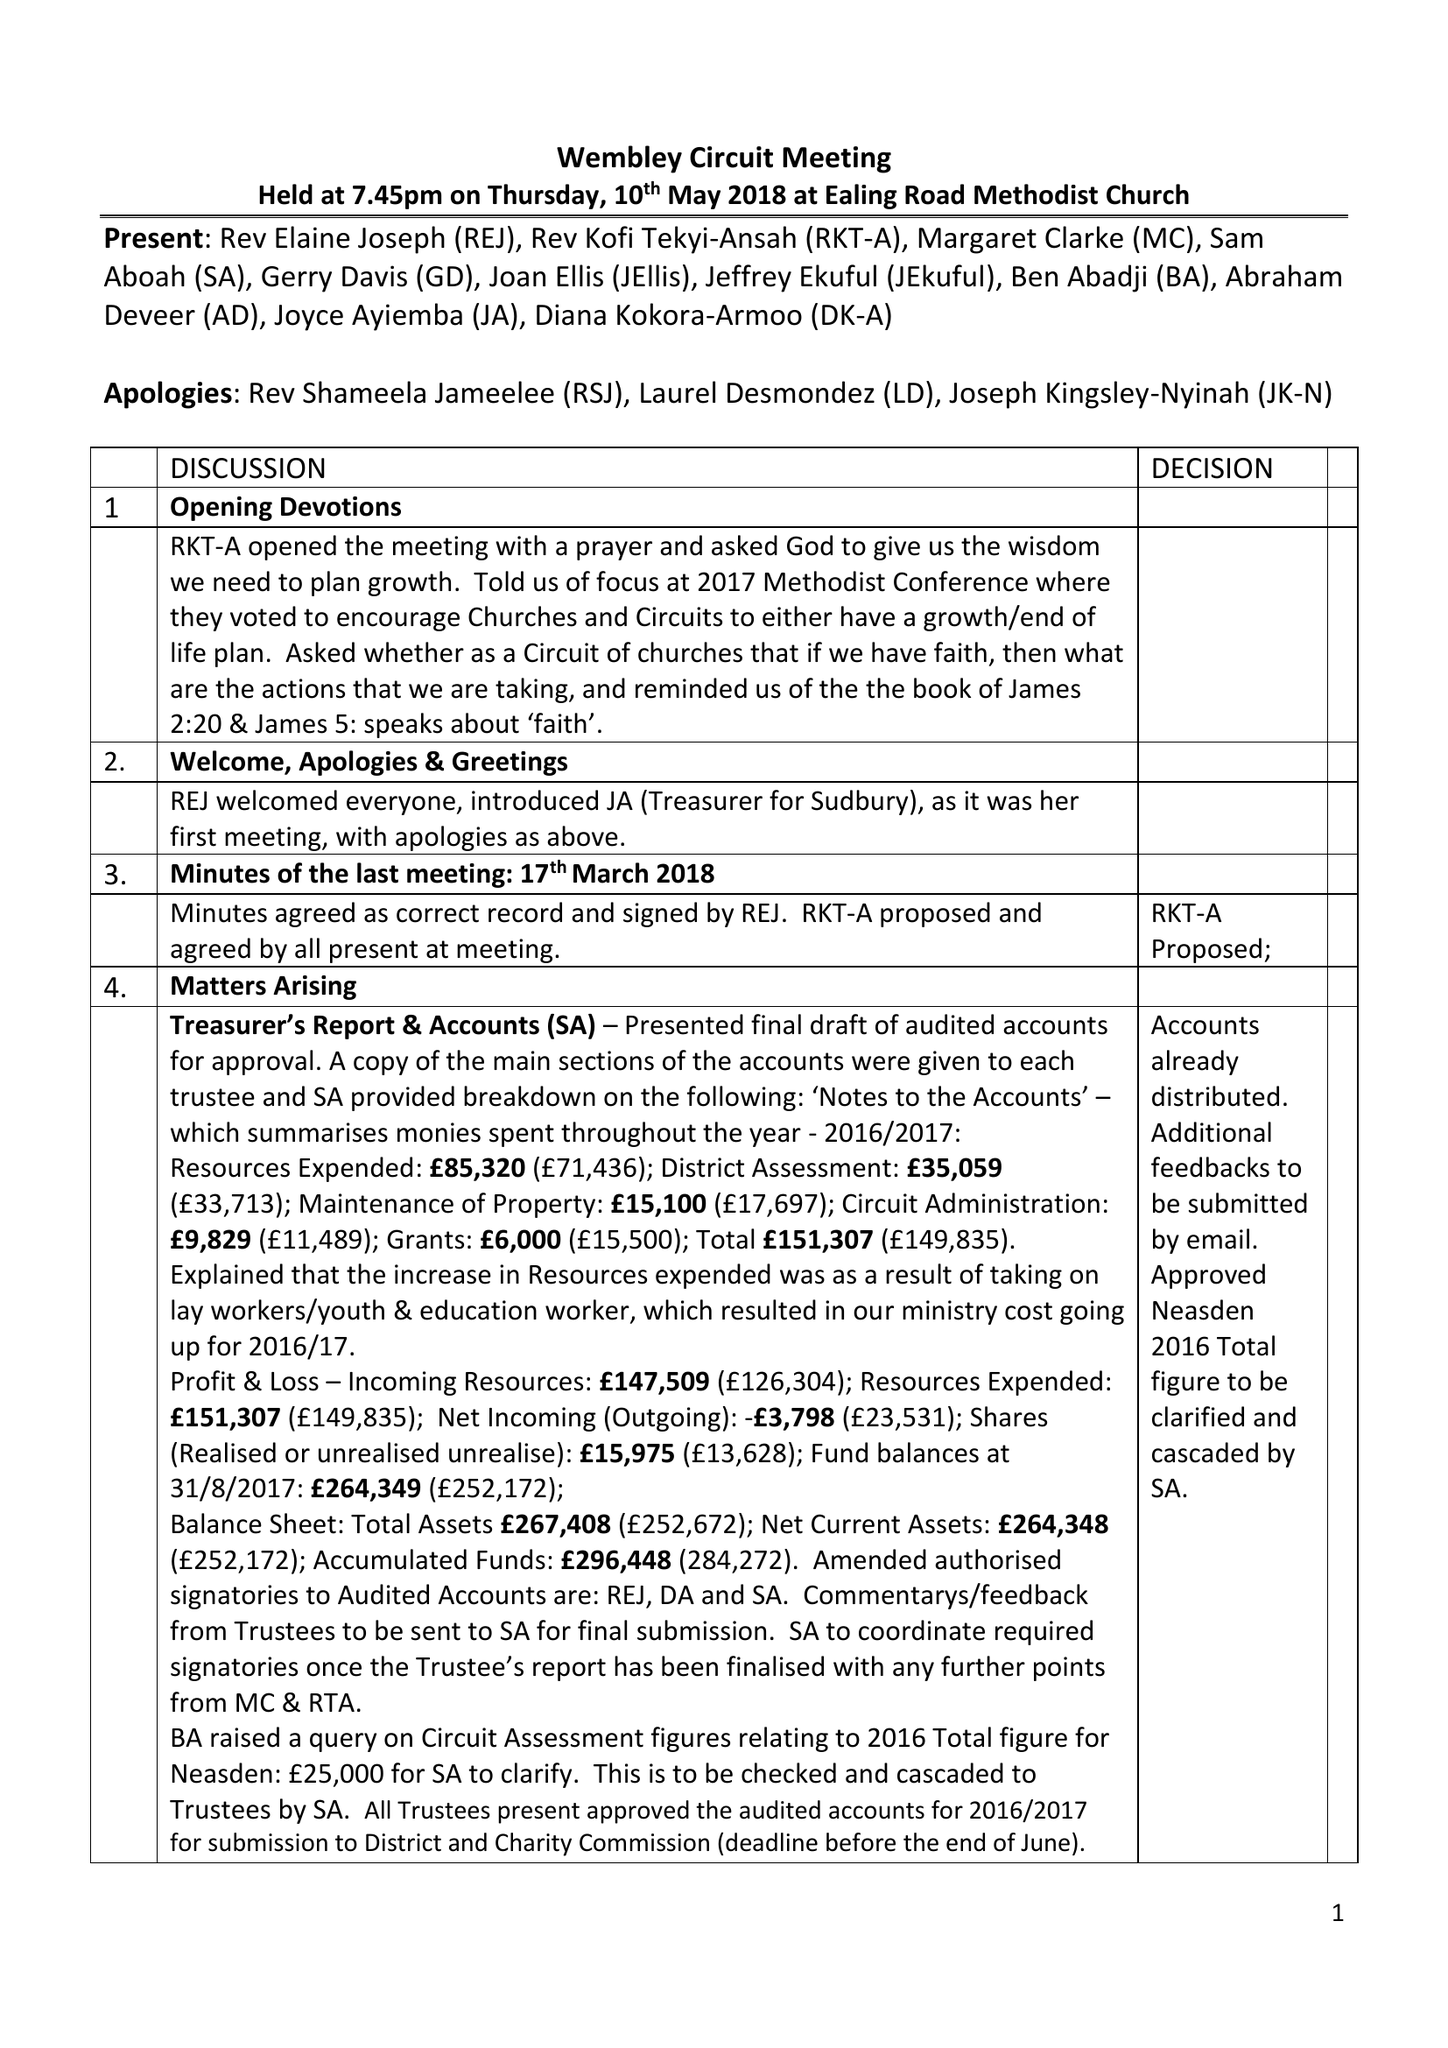What is the value for the income_annually_in_british_pounds?
Answer the question using a single word or phrase. 147509.00 